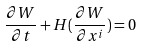<formula> <loc_0><loc_0><loc_500><loc_500>\frac { { \partial } W } { { \partial } t } + H ( \frac { { \partial } W } { { \partial } x ^ { i } } ) = 0</formula> 